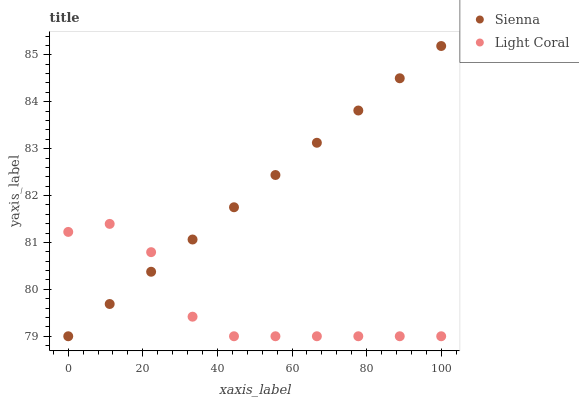Does Light Coral have the minimum area under the curve?
Answer yes or no. Yes. Does Sienna have the maximum area under the curve?
Answer yes or no. Yes. Does Light Coral have the maximum area under the curve?
Answer yes or no. No. Is Sienna the smoothest?
Answer yes or no. Yes. Is Light Coral the roughest?
Answer yes or no. Yes. Is Light Coral the smoothest?
Answer yes or no. No. Does Sienna have the lowest value?
Answer yes or no. Yes. Does Sienna have the highest value?
Answer yes or no. Yes. Does Light Coral have the highest value?
Answer yes or no. No. Does Sienna intersect Light Coral?
Answer yes or no. Yes. Is Sienna less than Light Coral?
Answer yes or no. No. Is Sienna greater than Light Coral?
Answer yes or no. No. 